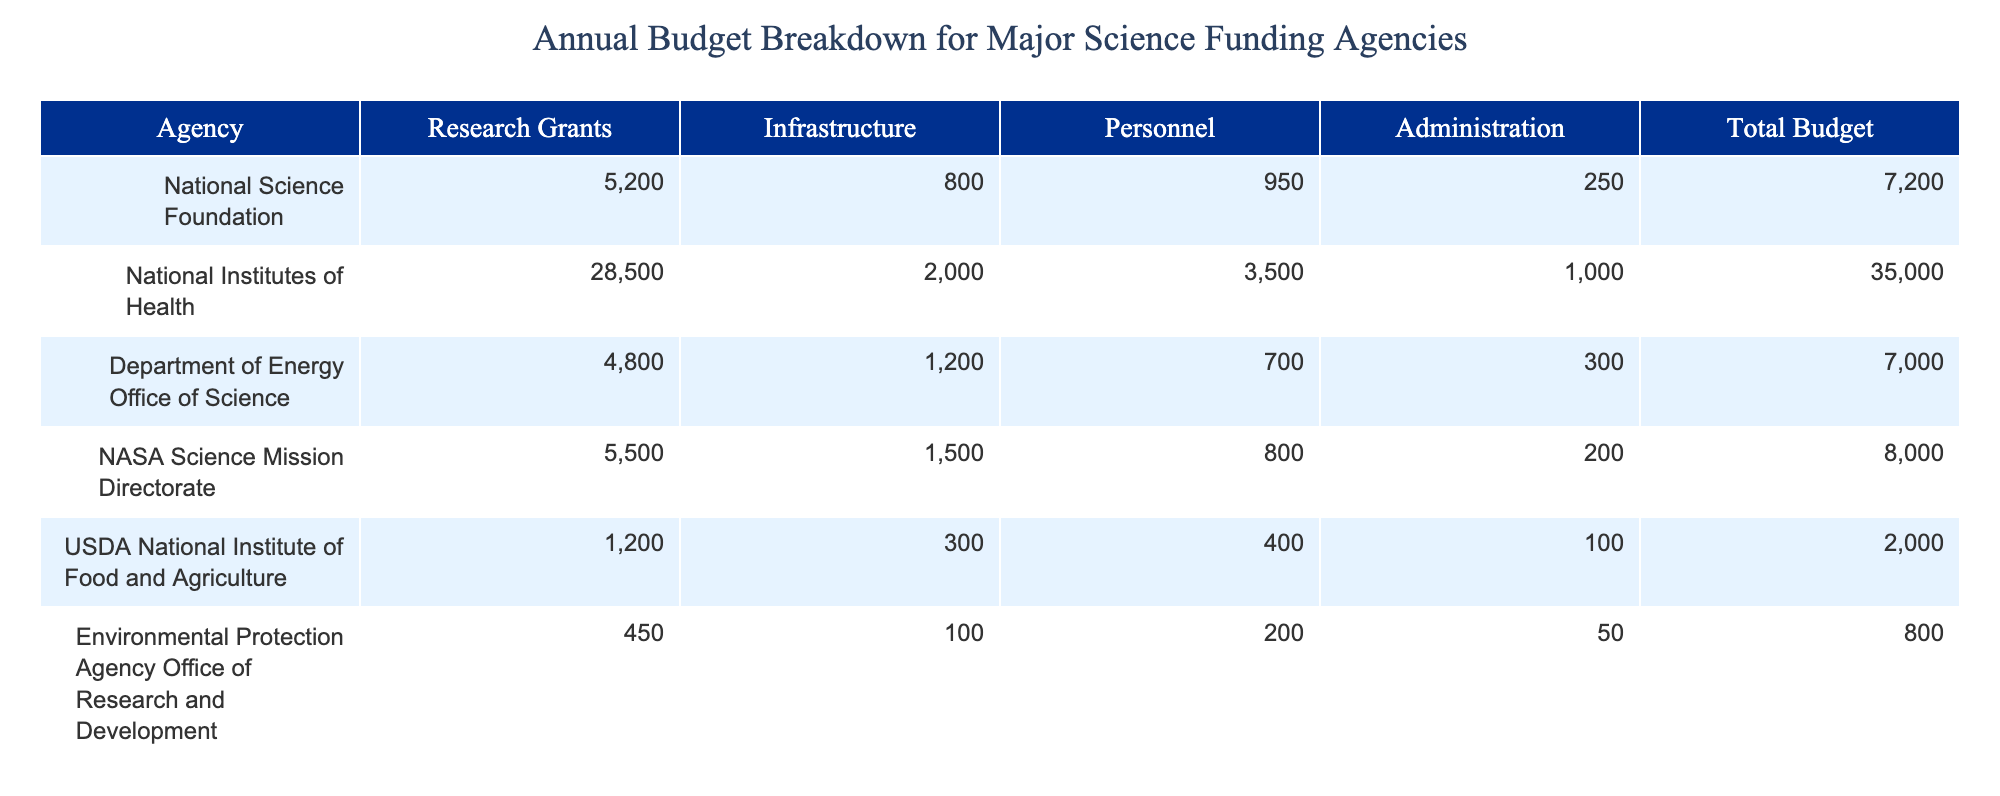What is the total budget for the National Institutes of Health? The total budget for the National Institutes of Health is explicitly listed in the table. Looking at the row for this agency, the total budget amount is 35000.
Answer: 35000 What percentage of the total budget for NASA Science Mission Directorate is allocated to Research Grants? To find the percentage allocated to Research Grants, divide the Research Grants amount (5500) by the Total Budget (8000), then multiply by 100. The calculation is (5500/8000) * 100 = 68.75%.
Answer: 68.75% Does the Environmental Protection Agency Office of Research and Development have a higher budget for Administration than NOAA Office of Oceanic and Atmospheric Research? Looking at the Administration amounts for both agencies, EPA has 50 and NOAA has 50 as well. Since both are equal, the result is 'no'.
Answer: No Which agency has the largest allocation for Research Grants, and what is that amount? Reviewing the Research Grants column in the table, the National Institutes of Health has the highest figure at 28500, indicating the agency with the largest allocation for Research Grants.
Answer: 28500 What is the total amount allocated to Administration across all agencies? To calculate the total amount for Administration, sum the Administration values: 250 (NSF) + 1000 (NIH) + 300 (DOE) + 200 (NASA) + 100 (USDA) + 50 (EPA) + 50 (NOAA) = 1950.
Answer: 1950 Is the total budget for the National Science Foundation less than that of the Department of Energy Office of Science? Comparing the Total Budgets, NSF has 7200 and DOE has 7000. Since 7200 is greater than 7000, the answer is 'no'.
Answer: No What is the average total budget across all agencies shown in the table? To find the average total budget, sum the Total Budgets for all agencies: 7200 + 35000 + 7000 + 8000 + 2000 + 800 + 700 = 51900. Then divide this by the number of agencies (7). The average is 51900 / 7 = 7414.29.
Answer: 7414.29 Which agency receives the least funding for Personnel, and what is that amount? Looking at the Personnel column, the USDA National Institute of Food and Agriculture has the lowest figure at 400, making it the agency that receives the least funding for Personnel.
Answer: 400 How much more does the National Institutes of Health spend on Research Grants compared to the USDA National Institute of Food and Agriculture? The amount for NIH in Research Grants is 28500 and for USDA is 1200. The difference is calculated as 28500 - 1200 = 27300, indicating how much more NIH spends.
Answer: 27300 